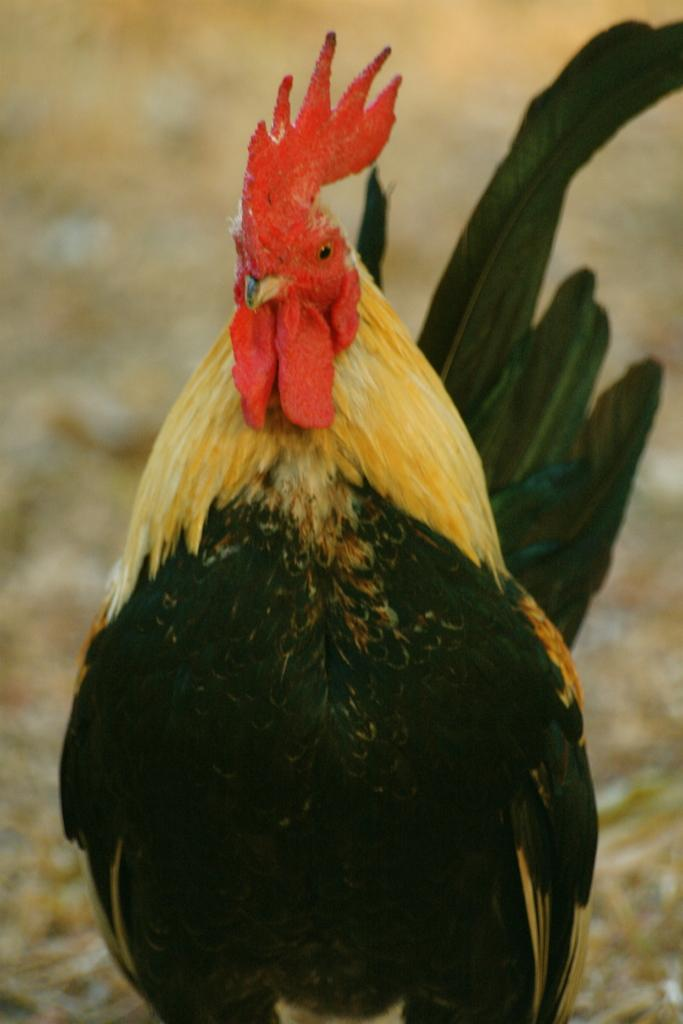What is the main subject of the image? There is a cock in the middle of the image. What type of iron can be seen in the image? There is no iron present in the image; it features a cock as the main subject. How many hammers are visible in the image? There are no hammers visible in the image; it features a cock as the main subject. 